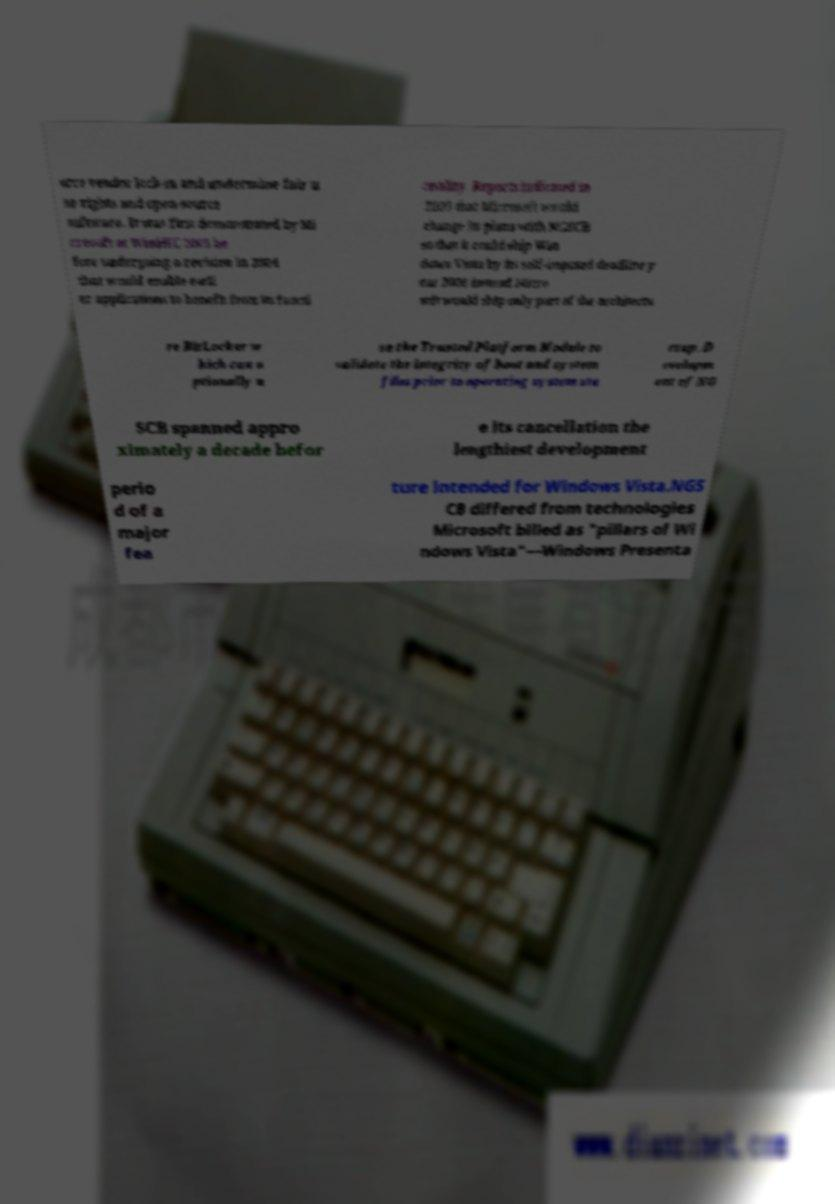Could you assist in decoding the text presented in this image and type it out clearly? orce vendor lock-in and undermine fair u se rights and open-source software. It was first demonstrated by Mi crosoft at WinHEC 2003 be fore undergoing a revision in 2004 that would enable earli er applications to benefit from its functi onality. Reports indicated in 2005 that Microsoft would change its plans with NGSCB so that it could ship Win dows Vista by its self-imposed deadline y ear 2006 instead Micro soft would ship only part of the architectu re BitLocker w hich can o ptionally u se the Trusted Platform Module to validate the integrity of boot and system files prior to operating system sta rtup. D evelopm ent of NG SCB spanned appro ximately a decade befor e its cancellation the lengthiest development perio d of a major fea ture intended for Windows Vista.NGS CB differed from technologies Microsoft billed as "pillars of Wi ndows Vista"—Windows Presenta 